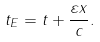Convert formula to latex. <formula><loc_0><loc_0><loc_500><loc_500>t _ { E } = t + \frac { \varepsilon x } { c } .</formula> 